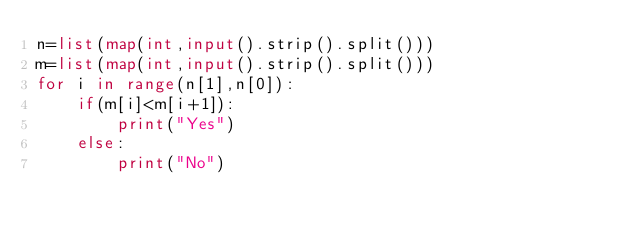<code> <loc_0><loc_0><loc_500><loc_500><_Python_>n=list(map(int,input().strip().split()))
m=list(map(int,input().strip().split()))
for i in range(n[1],n[0]):
    if(m[i]<m[i+1]):
        print("Yes")
    else:
        print("No")</code> 